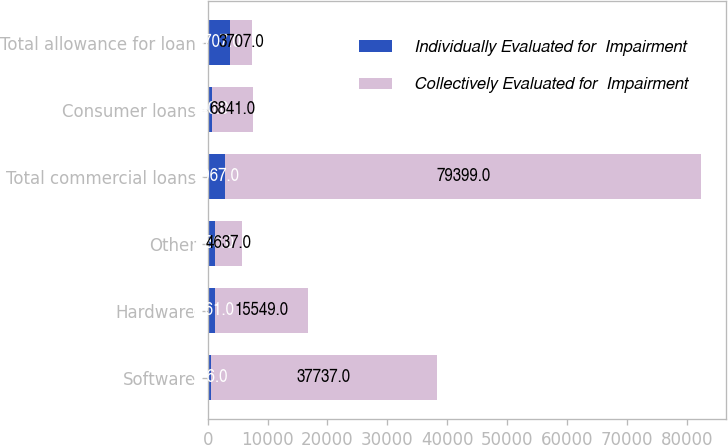Convert chart to OTSL. <chart><loc_0><loc_0><loc_500><loc_500><stacked_bar_chart><ecel><fcel>Software<fcel>Hardware<fcel>Other<fcel>Total commercial loans<fcel>Consumer loans<fcel>Total allowance for loan<nl><fcel>Individually Evaluated for  Impairment<fcel>526<fcel>1261<fcel>1180<fcel>2967<fcel>740<fcel>3707<nl><fcel>Collectively Evaluated for  Impairment<fcel>37737<fcel>15549<fcel>4637<fcel>79399<fcel>6841<fcel>3707<nl></chart> 